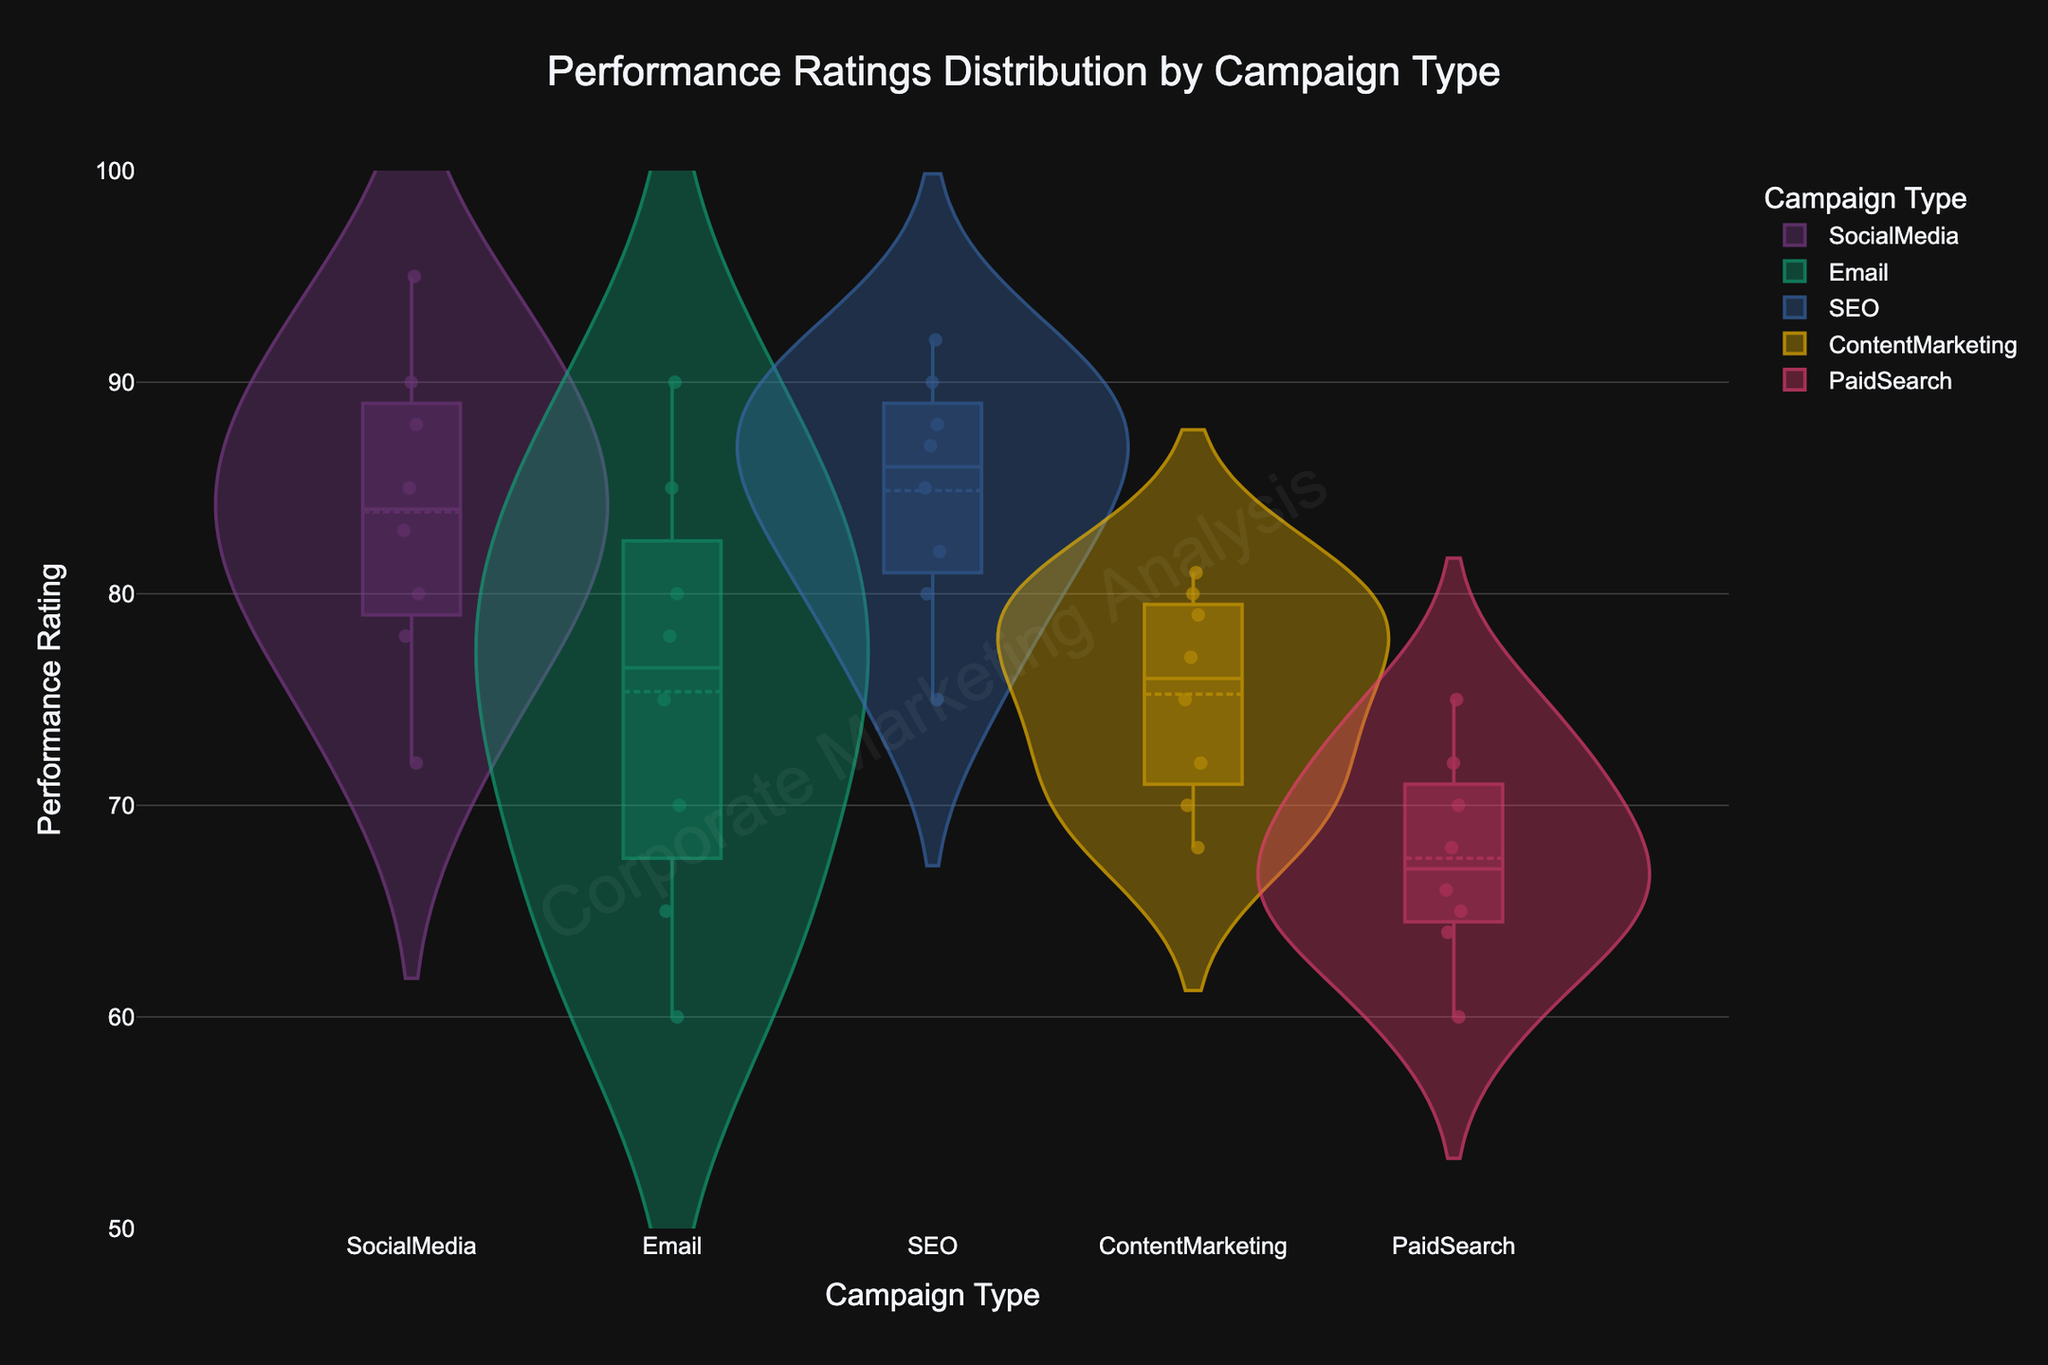What's the title of the chart? The title is displayed at the top of the chart, indicating the main topic it covers. In this case, the title reads "Performance Ratings Distribution by Campaign Type."
Answer: Performance Ratings Distribution by Campaign Type What is the range of the y-axis? The y-axis displays the range of performance ratings. The chart shows this range from 50 to 100, with tick marks at intervals typically displayed.
Answer: 50 to 100 Which campaign type has the widest distribution of performance ratings? By examining the spread of the violin plots, we can see that "PaidSearch" has a wide distribution with ratings ranging roughly from 60 to 75.
Answer: PaidSearch Which campaign type has the highest median performance rating? The median is shown by a horizontal line within the plot. The "SEO" campaign type has the highest median performance rating, indicated by the position of its median line.
Answer: SEO How many performance ratings are there for Content Marketing? By counting the individual data points displayed within the "ContentMarketing" violin plot, we see that there are 8 performance ratings for Content Marketing.
Answer: 8 Compare the median of SocialMedia and Email campaigns. Which one is higher? The median for each campaign is indicated by a line within the violin plot. The median for "SocialMedia" is higher compared to "Email."
Answer: SocialMedia Which campaign type has the smallest interquartile range (IQR)? The IQR is represented by the width of the central part of the violin plot (where the box is). "Email" has the smallest IQR since its box is the narrowest among all.
Answer: Email What is the minimum performance rating for Paid Search campaigns? The minimum rating is indicated by the lowest point within the violin plot for "PaidSearch." The lowest point is found near a rating of 60.
Answer: 60 Examine the distribution of Email campaign performance ratings. Where do most of the ratings cluster? Most of the performance ratings for "Email" cluster around the mid-range, especially around the 75-80 region, as indicated by the bulge in the plot.
Answer: 75-80 Which campaign type has the most evenly distributed performance ratings? An evenly distributed plot will be more uniformly wide throughout. "ContentMarketing" has a more evenly distributed range without extreme bulges or narrow sections.
Answer: ContentMarketing 